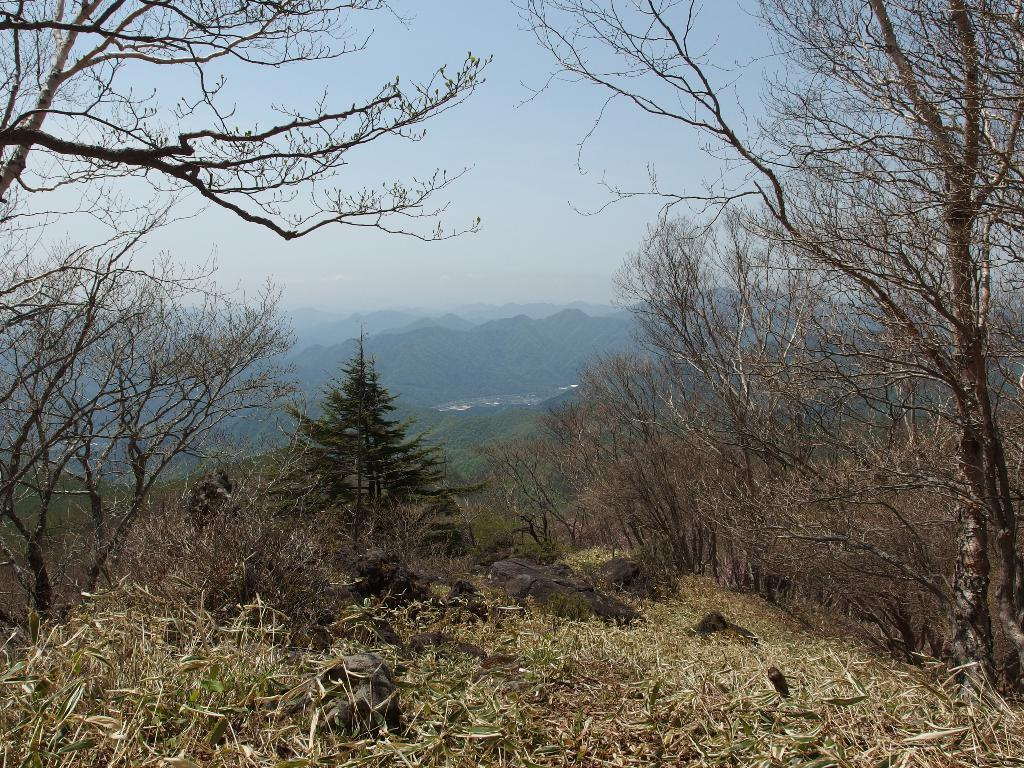What type of vegetation can be seen in the image? There are trees in the image. What type of terrain is visible in the image? There are hills in the image. What can be seen in the sky in the image? There are clouds in the image. What is visible in the background of the image? The sky is visible in the image. What type of ground cover is present at the bottom of the image? There is grass at the bottom of the image. What type of apparel is being worn by the kite in the image? There is no kite present in the image, so it is not possible to determine what type of apparel it might be wearing. 